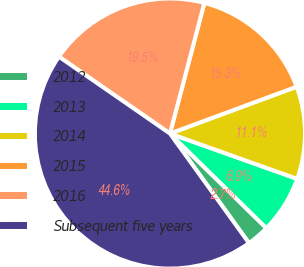<chart> <loc_0><loc_0><loc_500><loc_500><pie_chart><fcel>2012<fcel>2013<fcel>2014<fcel>2015<fcel>2016<fcel>Subsequent five years<nl><fcel>2.71%<fcel>6.9%<fcel>11.08%<fcel>15.27%<fcel>19.46%<fcel>44.58%<nl></chart> 